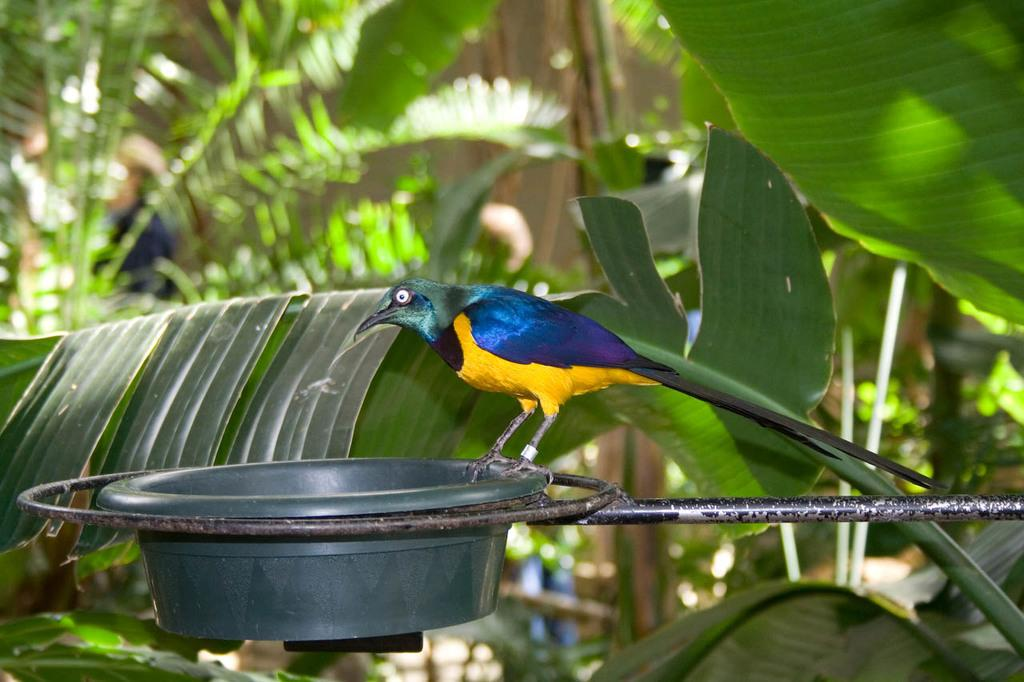What is the main object in the image? There is a bird feeder in the image. Is there any activity involving the bird feeder? Yes, there is a bird on the bird feeder. What can be seen in the background of the image? Leaves are visible in the background of the image. What family member is telling a story about the bird feeder in the image? There is no family member present in the image, nor is there any indication of a story being told. 